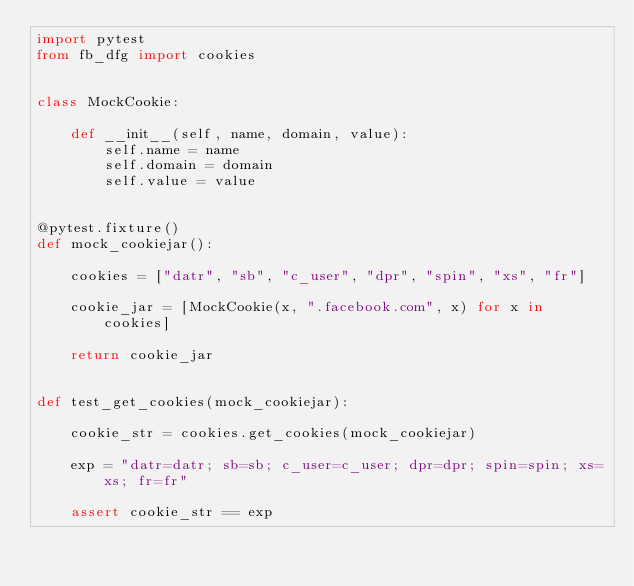<code> <loc_0><loc_0><loc_500><loc_500><_Python_>import pytest
from fb_dfg import cookies


class MockCookie:

    def __init__(self, name, domain, value):
        self.name = name
        self.domain = domain
        self.value = value


@pytest.fixture()
def mock_cookiejar():

    cookies = ["datr", "sb", "c_user", "dpr", "spin", "xs", "fr"]

    cookie_jar = [MockCookie(x, ".facebook.com", x) for x in cookies]

    return cookie_jar


def test_get_cookies(mock_cookiejar):

    cookie_str = cookies.get_cookies(mock_cookiejar)

    exp = "datr=datr; sb=sb; c_user=c_user; dpr=dpr; spin=spin; xs=xs; fr=fr"

    assert cookie_str == exp
</code> 